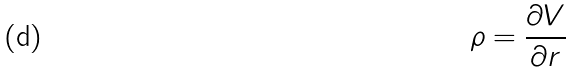<formula> <loc_0><loc_0><loc_500><loc_500>\rho = \frac { \partial V } { \partial r }</formula> 